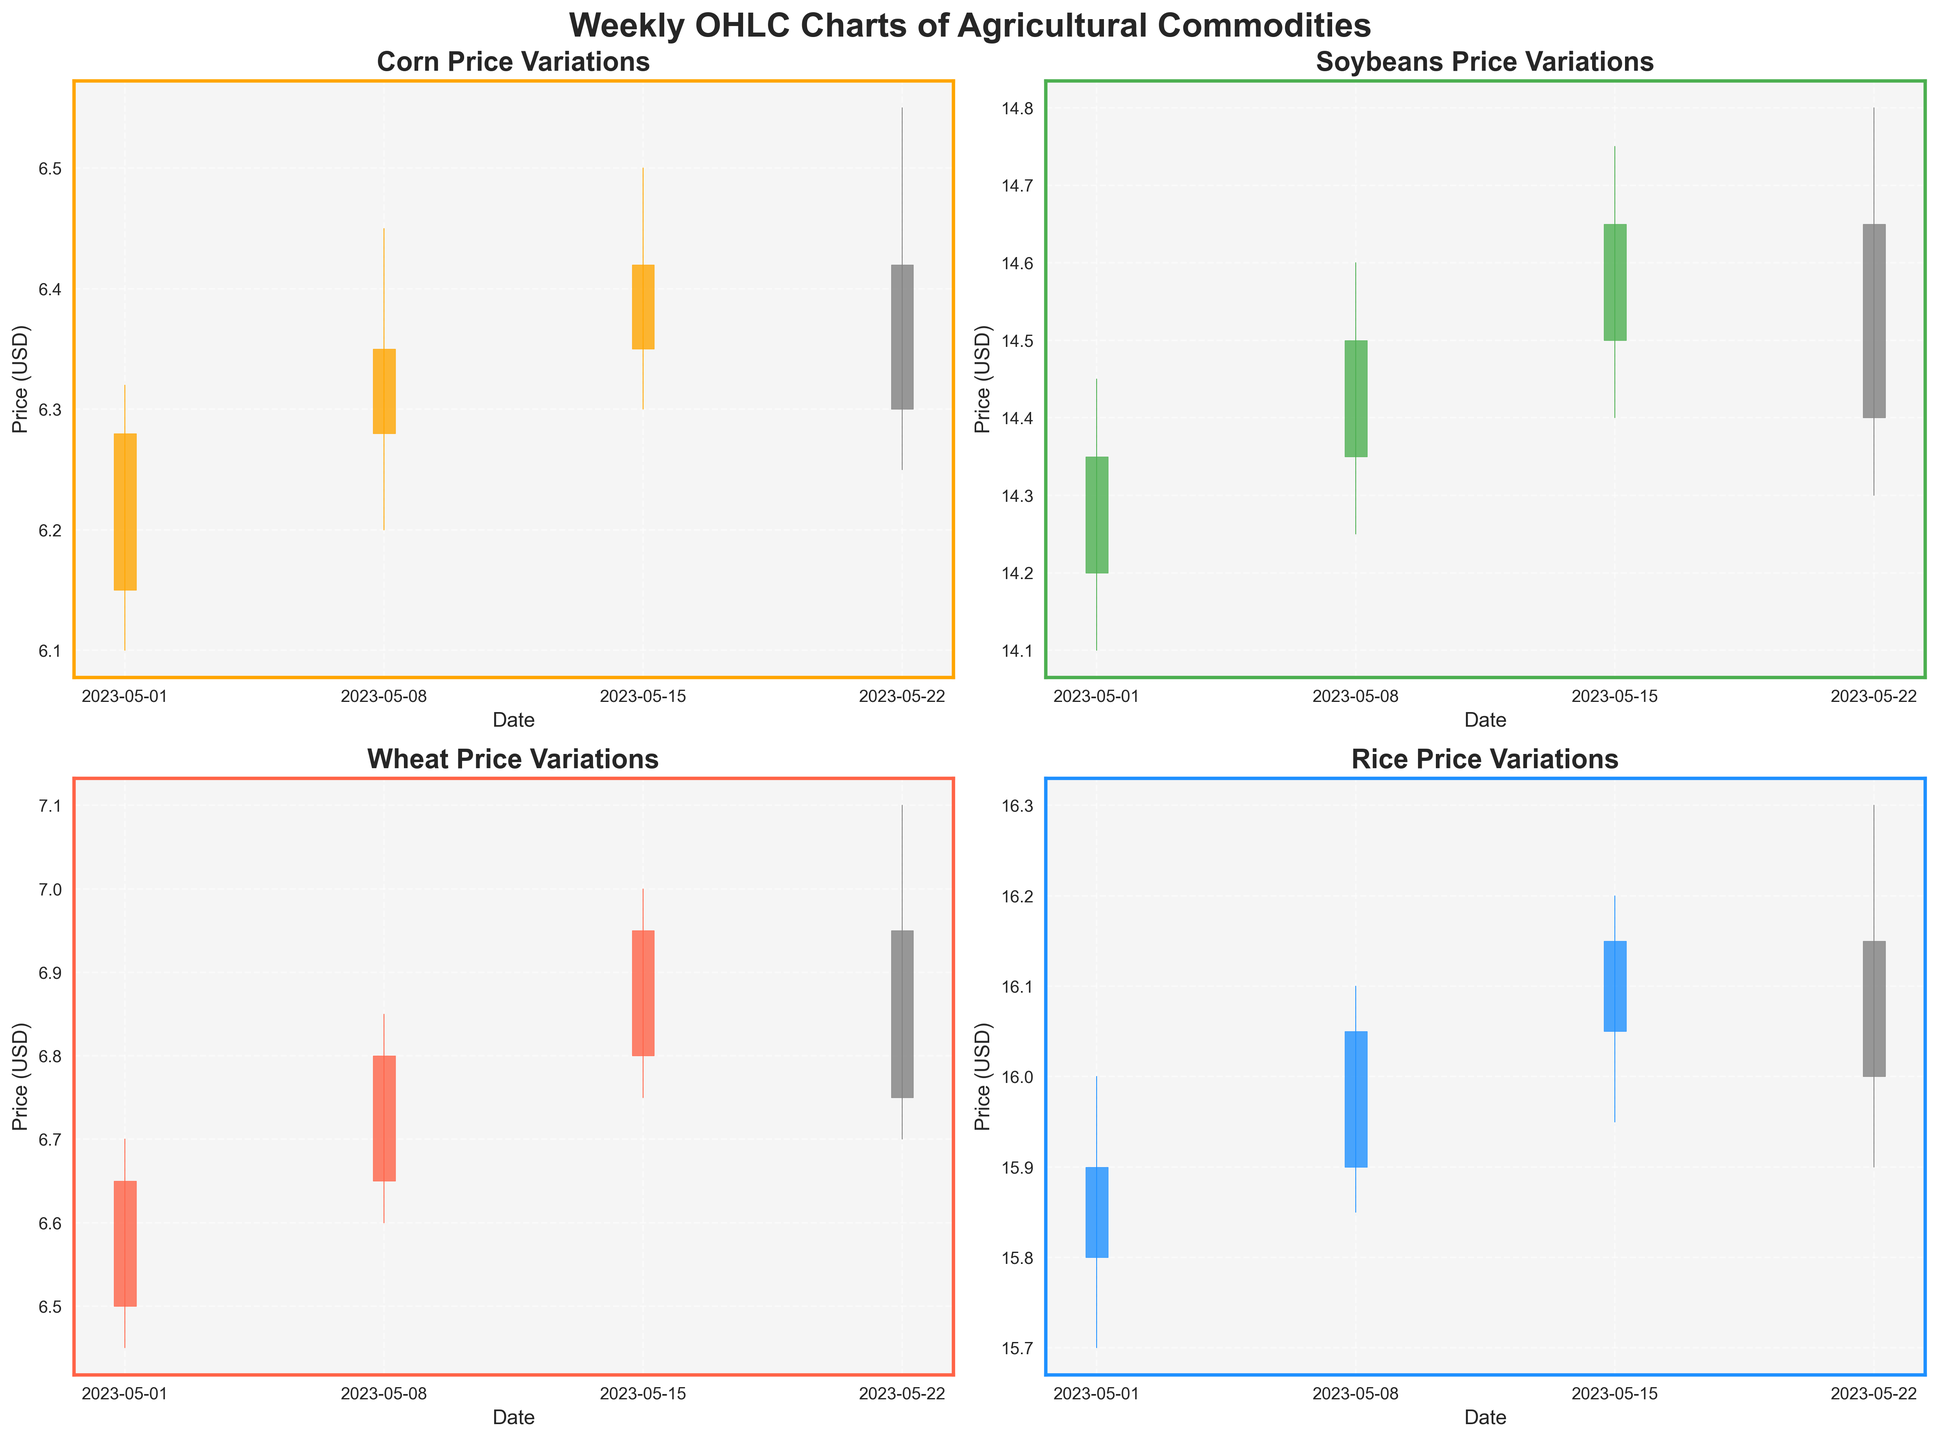Which commodity has the highest closing price in the first week of May? Look at the closing prices of all commodities for the week beginning May 1st. Corn is $6.28, Soybeans are $14.35, Wheat is $6.65, and Rice is $15.90. Rice has the highest closing price.
Answer: Rice What is the overall trend of corn prices over the weeks displayed? To determine the trend, observe the closing prices of Corn each week. The prices are $6.28, $6.35, $6.42, and $6.30, respectively. Corn prices initially increase and then slightly decrease.
Answer: Increasing, then decreasing Between Wheat and Soybeans, which commodity showed the greatest price drop in the last week of May? Compare the closing prices for Wheat and Soybeans for the week starting May 22nd with their corresponding high prices. Wheat dropped from $7.10 to $6.75 (a $0.35 drop), and Soybeans dropped from $14.80 to $14.40 (a $0.40 drop). Therefore, Soybeans had the greater price drop.
Answer: Soybeans Which commodity experienced the greatest price increase from the opening to the closing price in any single week? Compare week-by-week gains for each commodity: 
- Corn's largest increase: $6.28 - $6.15 = $0.13.
- Soybeans' largest increase: $14.65 - $14.50 = $0.15.
- Wheat's largest increase: $6.95 - $6.80 = $0.15.
- Rice's largest increase: $16.15 - $15.90 = $0.25. 
Rice has the greatest increase of $0.25 in one week (from May 8 to May 15).
Answer: Rice In the week starting May 15th, which commodity had the smallest difference between its high and low prices? Compare the high and low prices for the week starting May 15th:
- Corn: $6.50 - $6.30 = $0.20
- Soybeans: $14.75 - $14.40 = $0.35
- Wheat: $7.00 - $6.75 = $0.25
- Rice: $16.20 - $15.95 = $0.25
Corn had the smallest range with $0.20.
Answer: Corn Looking at the full data range, which commodity's closing price is most volatile? Volatility can be inferred by observing the variations in the closing prices over the period. Corn fluctuates between $6.28 and $6.42, Soybeans between $14.35 and $14.65, Wheat between $6.65 and $6.95, and Rice between $15.90 and $16.15. Soybeans show the highest volatility overall.
Answer: Soybeans How does the overall performance of Wheat compare to Corn over the displayed weeks? Evaluate weekly closing prices for Wheat ($6.65, $6.80, $6.95, $6.75) and Corn ($6.28, $6.35, $6.42, $6.30). Wheat shows a larger overall increase then decrease versus the more modest changes in Corn.
Answer: Wheat had more significant increases and decreases 